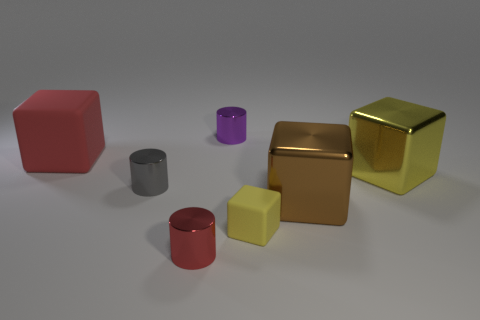How big is the metal cylinder that is on the right side of the tiny red shiny thing to the left of the purple thing?
Provide a succinct answer. Small. What is the shape of the big yellow object?
Provide a succinct answer. Cube. There is a red thing that is right of the red block; what material is it?
Ensure brevity in your answer.  Metal. What is the color of the metal thing that is in front of the small thing to the right of the tiny metal thing that is behind the big red thing?
Offer a very short reply. Red. There is another matte block that is the same size as the brown block; what color is it?
Give a very brief answer. Red. How many metallic things are tiny gray cylinders or big objects?
Provide a succinct answer. 3. What is the color of the large thing that is made of the same material as the big brown block?
Your answer should be very brief. Yellow. What is the material of the large thing that is left of the purple cylinder that is left of the small yellow thing?
Ensure brevity in your answer.  Rubber. What number of objects are either large objects that are in front of the big red thing or metal objects that are in front of the small gray metallic thing?
Ensure brevity in your answer.  3. There is a matte block that is on the left side of the tiny red cylinder on the left side of the small metallic cylinder that is behind the gray metal object; what is its size?
Your response must be concise. Large. 